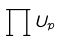Convert formula to latex. <formula><loc_0><loc_0><loc_500><loc_500>\prod U _ { p }</formula> 